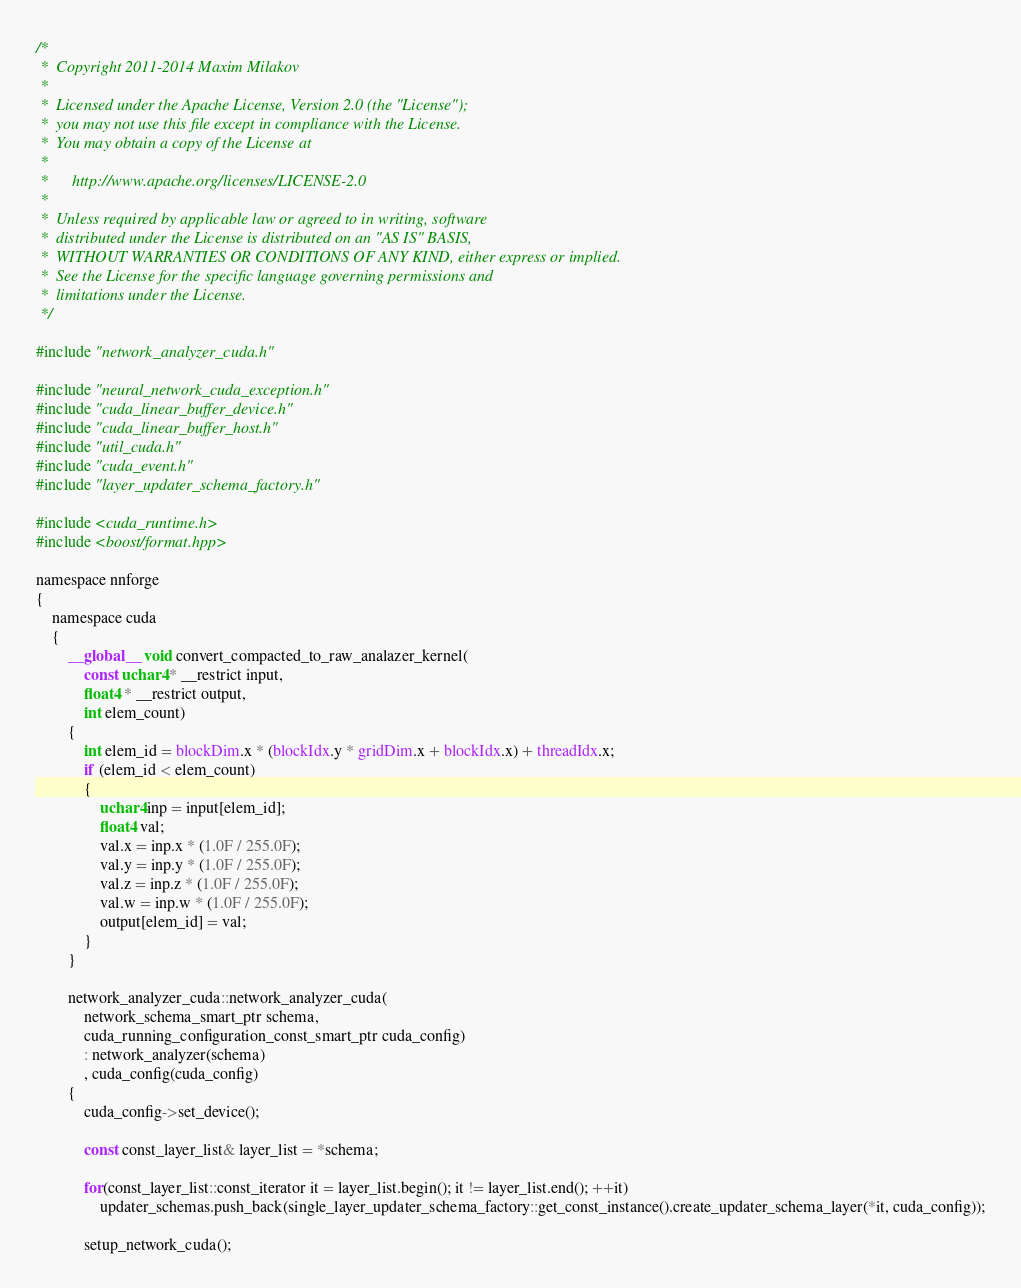Convert code to text. <code><loc_0><loc_0><loc_500><loc_500><_Cuda_>/*
 *  Copyright 2011-2014 Maxim Milakov
 *
 *  Licensed under the Apache License, Version 2.0 (the "License");
 *  you may not use this file except in compliance with the License.
 *  You may obtain a copy of the License at
 *
 *      http://www.apache.org/licenses/LICENSE-2.0
 *
 *  Unless required by applicable law or agreed to in writing, software
 *  distributed under the License is distributed on an "AS IS" BASIS,
 *  WITHOUT WARRANTIES OR CONDITIONS OF ANY KIND, either express or implied.
 *  See the License for the specific language governing permissions and
 *  limitations under the License.
 */

#include "network_analyzer_cuda.h"

#include "neural_network_cuda_exception.h"
#include "cuda_linear_buffer_device.h"
#include "cuda_linear_buffer_host.h"
#include "util_cuda.h"
#include "cuda_event.h"
#include "layer_updater_schema_factory.h"

#include <cuda_runtime.h>
#include <boost/format.hpp>

namespace nnforge
{
	namespace cuda
	{
		__global__ void convert_compacted_to_raw_analazer_kernel(
			const uchar4 * __restrict input,
			float4 * __restrict output,
			int elem_count)
		{
			int elem_id = blockDim.x * (blockIdx.y * gridDim.x + blockIdx.x) + threadIdx.x;
			if (elem_id < elem_count)
			{
				uchar4 inp = input[elem_id];
				float4 val;
				val.x = inp.x * (1.0F / 255.0F);
				val.y = inp.y * (1.0F / 255.0F);
				val.z = inp.z * (1.0F / 255.0F);
				val.w = inp.w * (1.0F / 255.0F);
				output[elem_id] = val;
			}
		}

		network_analyzer_cuda::network_analyzer_cuda(
			network_schema_smart_ptr schema,
			cuda_running_configuration_const_smart_ptr cuda_config)
			: network_analyzer(schema)
			, cuda_config(cuda_config)
		{
			cuda_config->set_device();

			const const_layer_list& layer_list = *schema;

			for(const_layer_list::const_iterator it = layer_list.begin(); it != layer_list.end(); ++it)
				updater_schemas.push_back(single_layer_updater_schema_factory::get_const_instance().create_updater_schema_layer(*it, cuda_config));

			setup_network_cuda();
</code> 